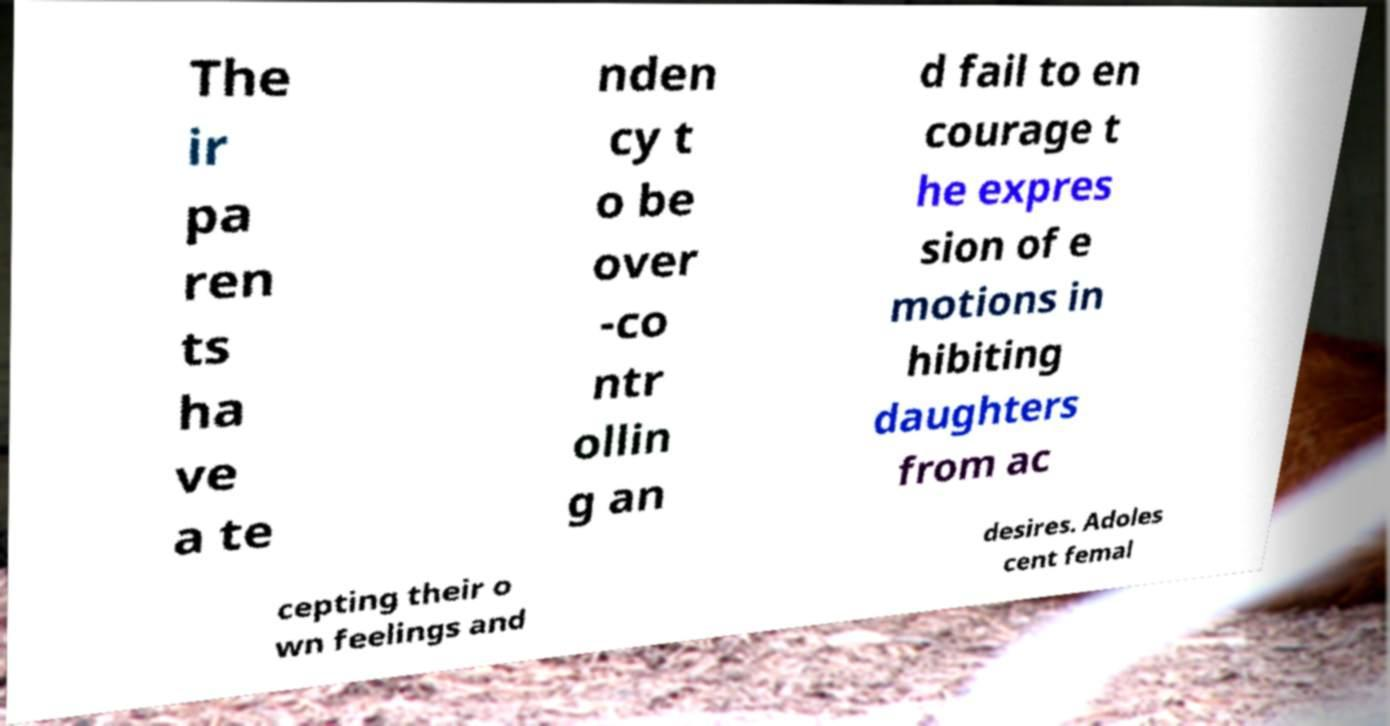Can you accurately transcribe the text from the provided image for me? The ir pa ren ts ha ve a te nden cy t o be over -co ntr ollin g an d fail to en courage t he expres sion of e motions in hibiting daughters from ac cepting their o wn feelings and desires. Adoles cent femal 